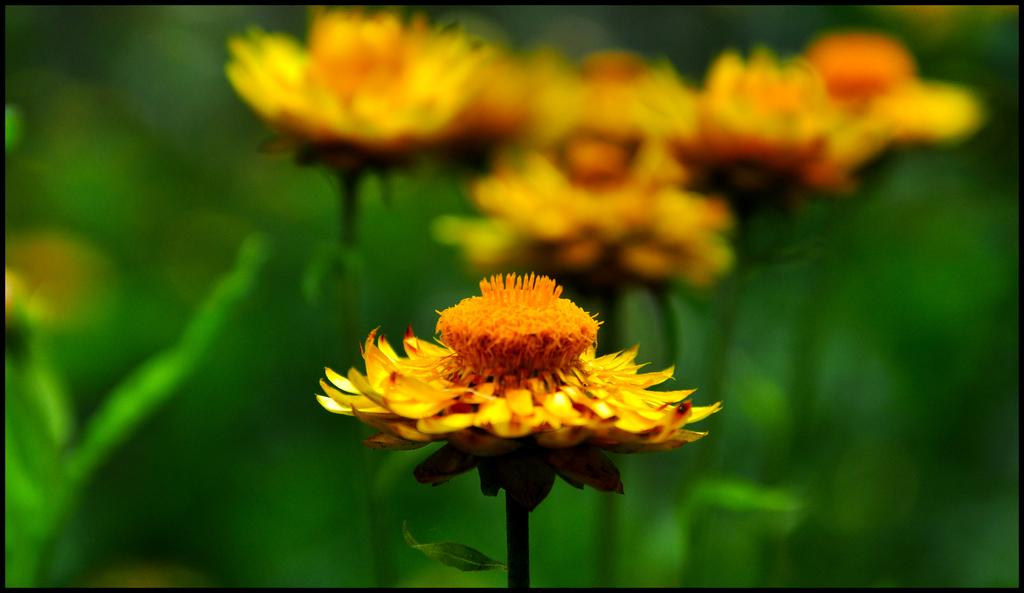What type of living organisms can be seen in the image? There are many plants in the image. What specific features can be observed on the plants? There are flowers on the plants in the image. What is the size of the skirt worn by the plants in the image? There is no skirt present in the image, as the main subjects are plants and flowers. 